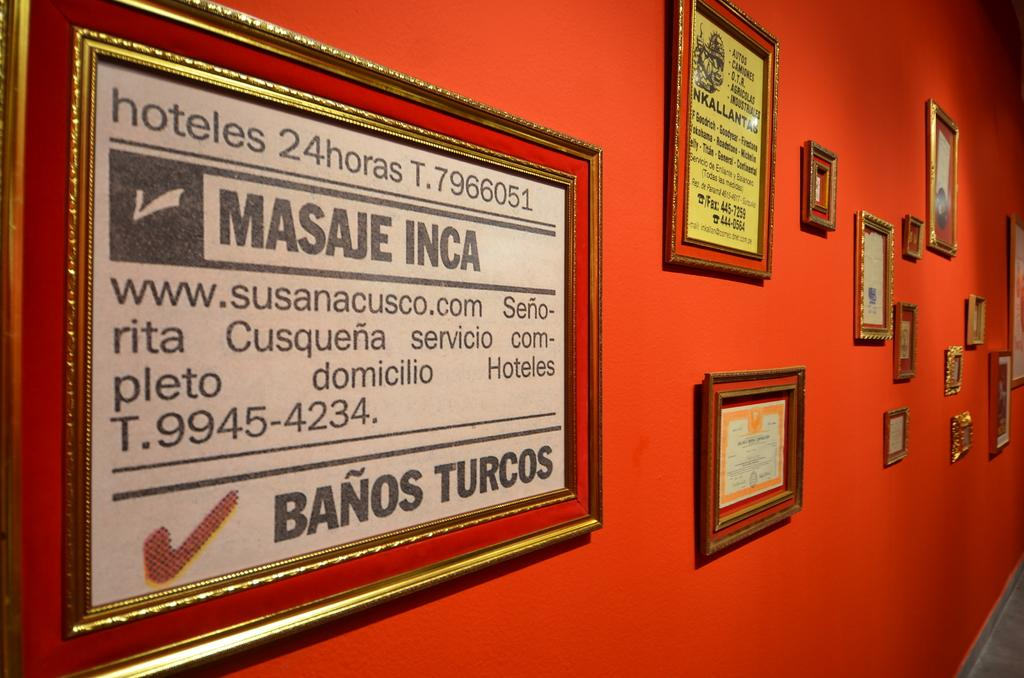<image>
Present a compact description of the photo's key features. Several framed signs are on a wall, including one that says Masaje Inca. 